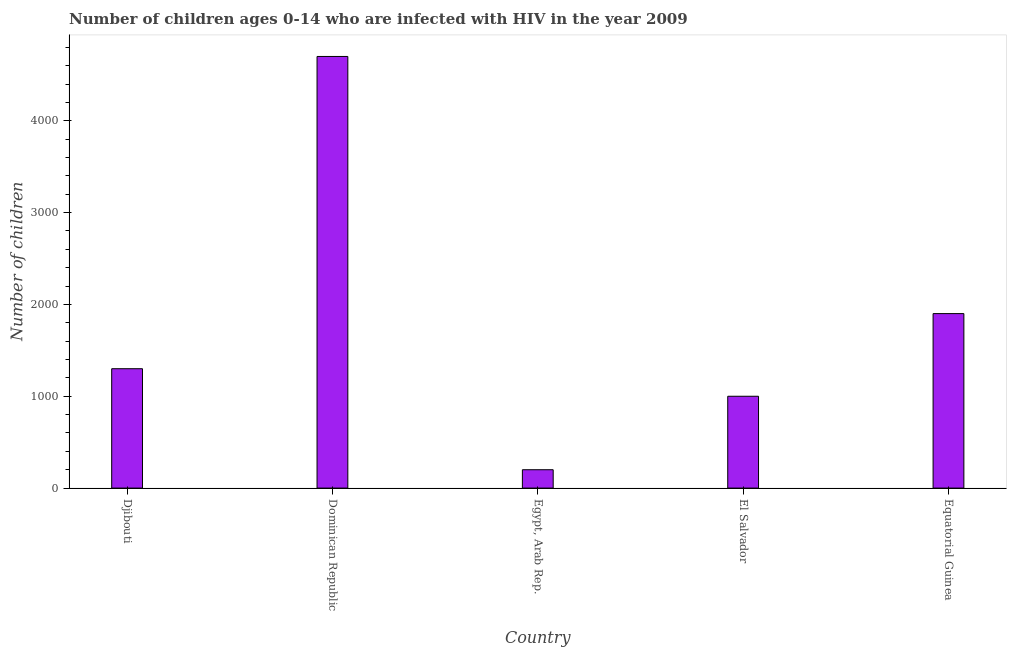Does the graph contain any zero values?
Provide a short and direct response. No. What is the title of the graph?
Keep it short and to the point. Number of children ages 0-14 who are infected with HIV in the year 2009. What is the label or title of the X-axis?
Your response must be concise. Country. What is the label or title of the Y-axis?
Give a very brief answer. Number of children. What is the number of children living with hiv in Equatorial Guinea?
Provide a short and direct response. 1900. Across all countries, what is the maximum number of children living with hiv?
Provide a succinct answer. 4700. Across all countries, what is the minimum number of children living with hiv?
Give a very brief answer. 200. In which country was the number of children living with hiv maximum?
Your response must be concise. Dominican Republic. In which country was the number of children living with hiv minimum?
Your answer should be very brief. Egypt, Arab Rep. What is the sum of the number of children living with hiv?
Offer a very short reply. 9100. What is the difference between the number of children living with hiv in Djibouti and El Salvador?
Your response must be concise. 300. What is the average number of children living with hiv per country?
Offer a very short reply. 1820. What is the median number of children living with hiv?
Your answer should be very brief. 1300. What is the ratio of the number of children living with hiv in Djibouti to that in Egypt, Arab Rep.?
Your response must be concise. 6.5. Is the number of children living with hiv in Egypt, Arab Rep. less than that in El Salvador?
Your answer should be compact. Yes. What is the difference between the highest and the second highest number of children living with hiv?
Your response must be concise. 2800. What is the difference between the highest and the lowest number of children living with hiv?
Ensure brevity in your answer.  4500. In how many countries, is the number of children living with hiv greater than the average number of children living with hiv taken over all countries?
Keep it short and to the point. 2. How many bars are there?
Make the answer very short. 5. What is the difference between two consecutive major ticks on the Y-axis?
Offer a very short reply. 1000. Are the values on the major ticks of Y-axis written in scientific E-notation?
Offer a very short reply. No. What is the Number of children of Djibouti?
Provide a short and direct response. 1300. What is the Number of children of Dominican Republic?
Provide a short and direct response. 4700. What is the Number of children in Egypt, Arab Rep.?
Ensure brevity in your answer.  200. What is the Number of children of Equatorial Guinea?
Provide a short and direct response. 1900. What is the difference between the Number of children in Djibouti and Dominican Republic?
Keep it short and to the point. -3400. What is the difference between the Number of children in Djibouti and Egypt, Arab Rep.?
Your response must be concise. 1100. What is the difference between the Number of children in Djibouti and El Salvador?
Make the answer very short. 300. What is the difference between the Number of children in Djibouti and Equatorial Guinea?
Your answer should be compact. -600. What is the difference between the Number of children in Dominican Republic and Egypt, Arab Rep.?
Provide a succinct answer. 4500. What is the difference between the Number of children in Dominican Republic and El Salvador?
Offer a very short reply. 3700. What is the difference between the Number of children in Dominican Republic and Equatorial Guinea?
Provide a short and direct response. 2800. What is the difference between the Number of children in Egypt, Arab Rep. and El Salvador?
Ensure brevity in your answer.  -800. What is the difference between the Number of children in Egypt, Arab Rep. and Equatorial Guinea?
Give a very brief answer. -1700. What is the difference between the Number of children in El Salvador and Equatorial Guinea?
Provide a short and direct response. -900. What is the ratio of the Number of children in Djibouti to that in Dominican Republic?
Keep it short and to the point. 0.28. What is the ratio of the Number of children in Djibouti to that in Egypt, Arab Rep.?
Offer a very short reply. 6.5. What is the ratio of the Number of children in Djibouti to that in Equatorial Guinea?
Make the answer very short. 0.68. What is the ratio of the Number of children in Dominican Republic to that in Egypt, Arab Rep.?
Offer a very short reply. 23.5. What is the ratio of the Number of children in Dominican Republic to that in Equatorial Guinea?
Your answer should be compact. 2.47. What is the ratio of the Number of children in Egypt, Arab Rep. to that in El Salvador?
Your answer should be compact. 0.2. What is the ratio of the Number of children in Egypt, Arab Rep. to that in Equatorial Guinea?
Your answer should be compact. 0.1. What is the ratio of the Number of children in El Salvador to that in Equatorial Guinea?
Your answer should be compact. 0.53. 